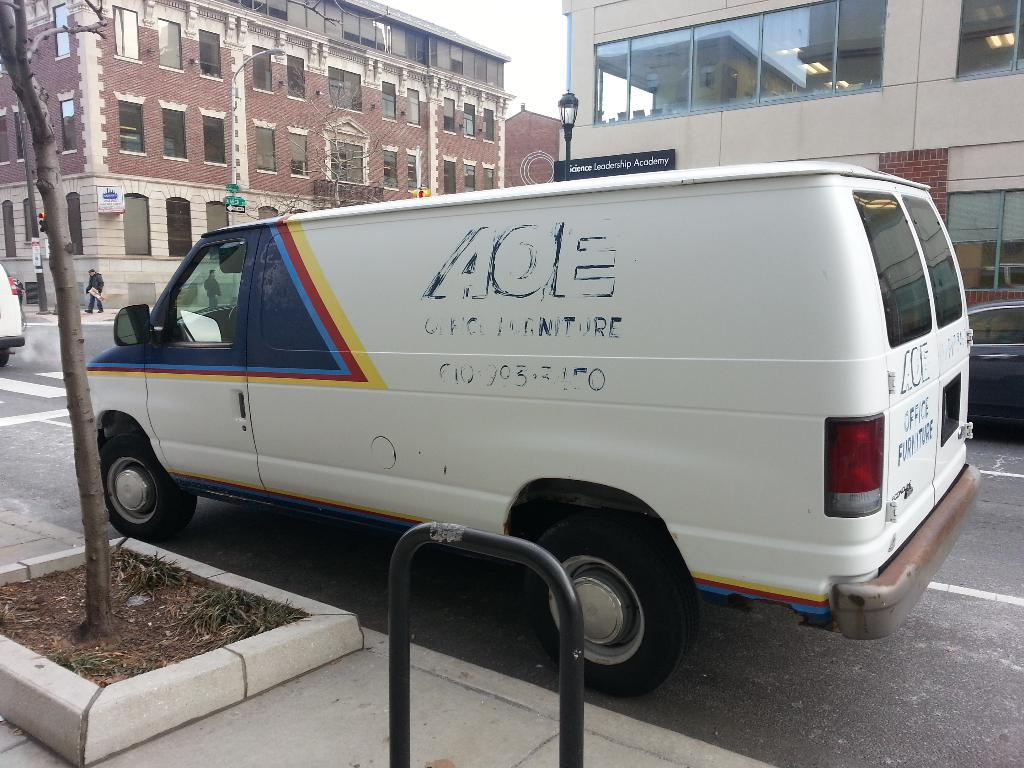What can be seen on the road in the image? There are vehicles on the road in the image. How many people are present in the image? There are two persons in the image. What type of structures can be seen in the image? There are buildings in the image. What objects are present that emit light? There are lights in the image. What type of signage is visible in the image? There are boards in the image. What type of vegetation is present in the image? There are trees in the image. What is visible in the background of the image? The sky is visible in the background of the image. Can you tell me how many children are playing with the ship in the image? There is no ship or children present in the image. What type of fuel is being used by the vehicles in the image? The image does not provide information about the type of fuel being used by the vehicles. 